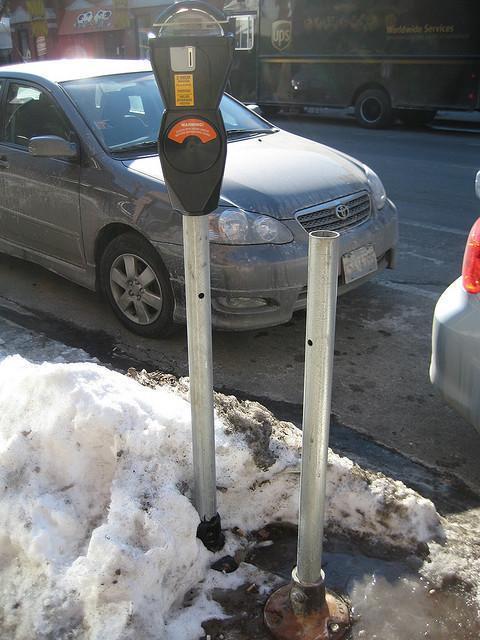How many cars are there?
Give a very brief answer. 2. How many parking meters are in the photo?
Give a very brief answer. 1. 